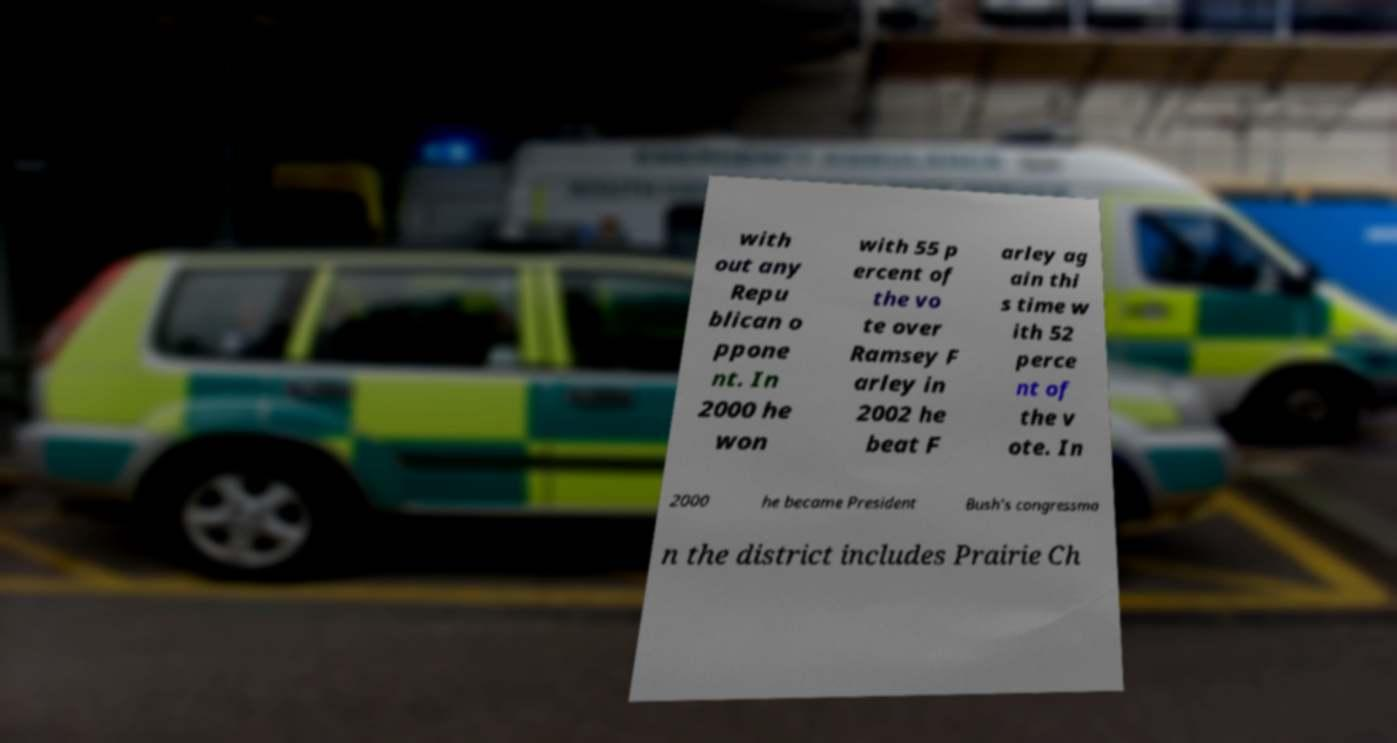Can you accurately transcribe the text from the provided image for me? with out any Repu blican o ppone nt. In 2000 he won with 55 p ercent of the vo te over Ramsey F arley in 2002 he beat F arley ag ain thi s time w ith 52 perce nt of the v ote. In 2000 he became President Bush's congressma n the district includes Prairie Ch 